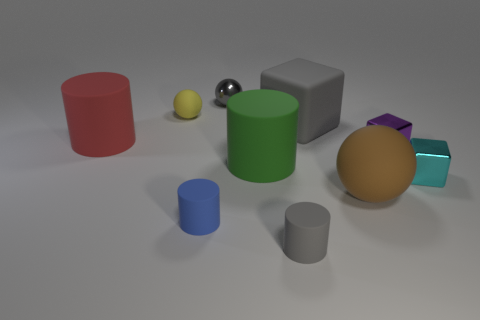Subtract all cylinders. How many objects are left? 6 Add 8 shiny balls. How many shiny balls exist? 9 Subtract 0 green blocks. How many objects are left? 10 Subtract all tiny gray balls. Subtract all small red matte cylinders. How many objects are left? 9 Add 9 tiny cyan cubes. How many tiny cyan cubes are left? 10 